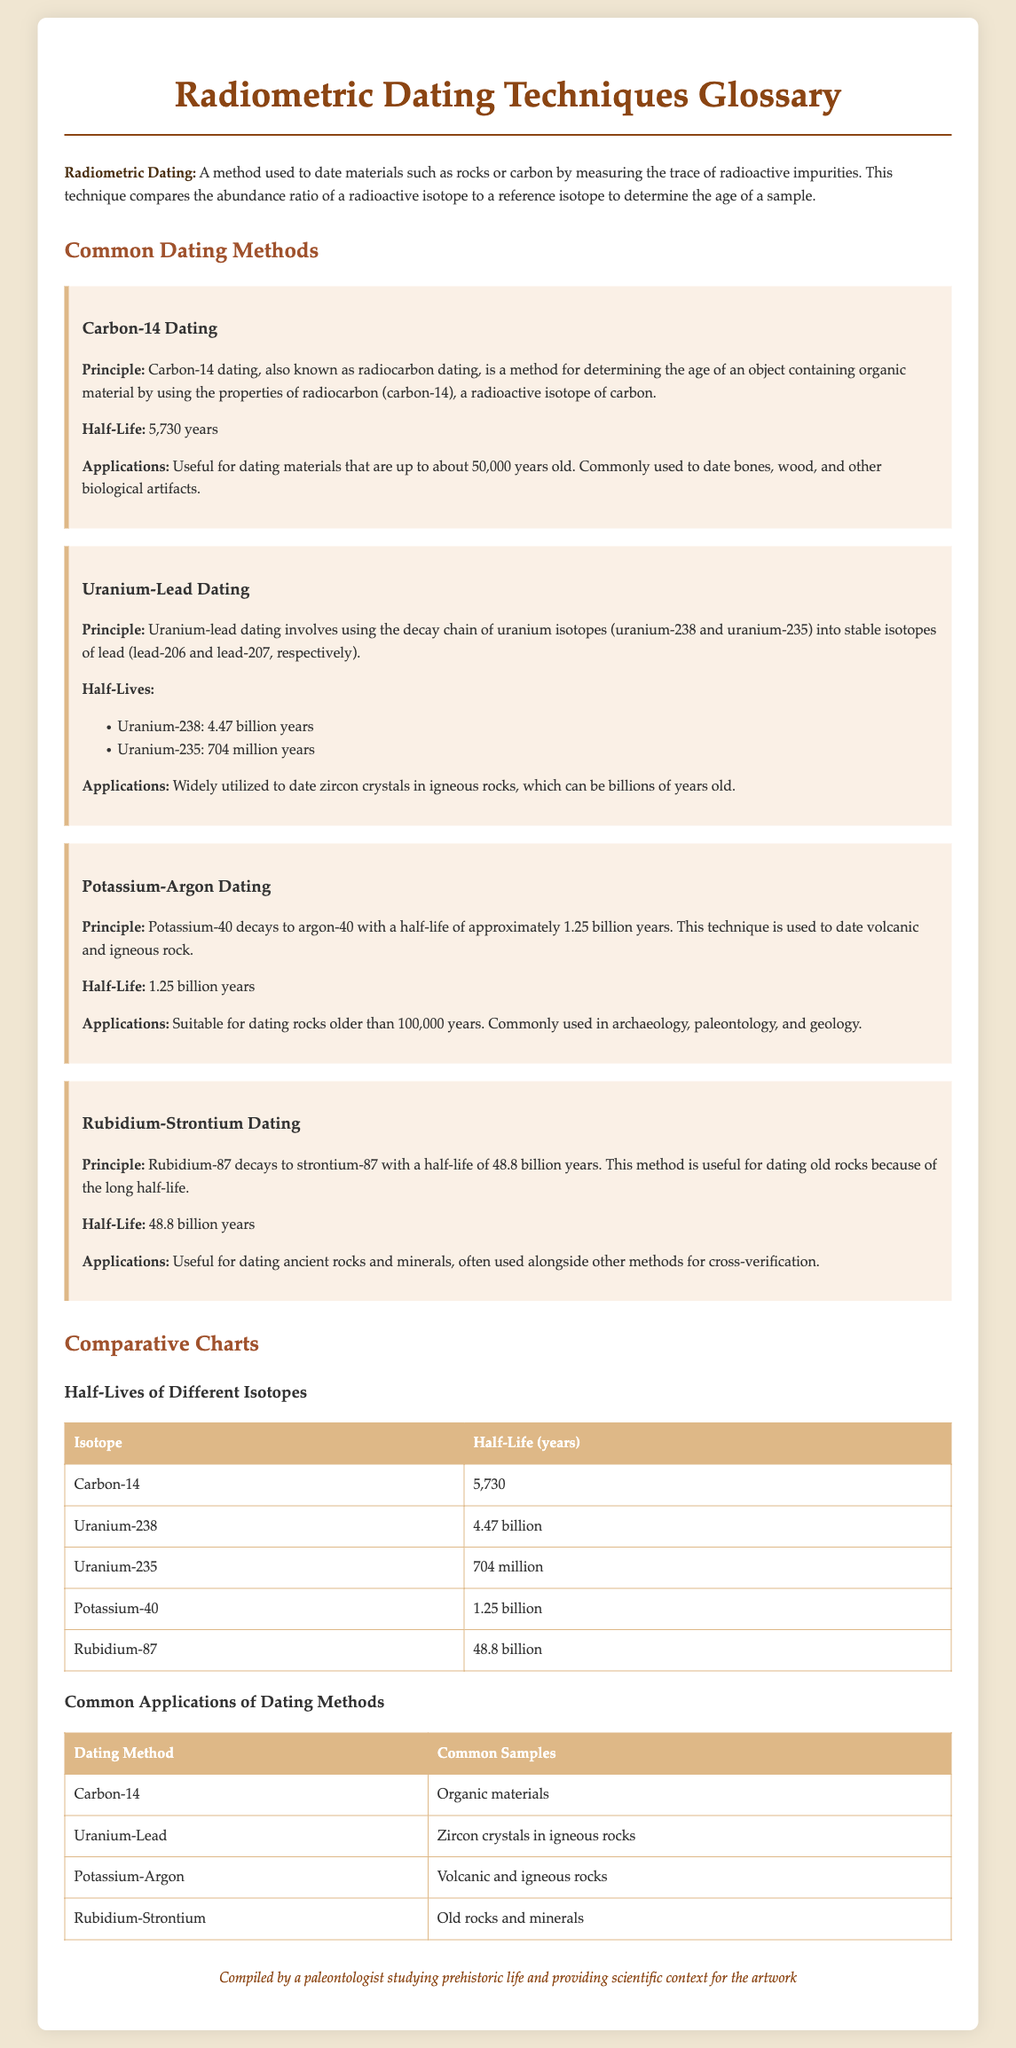What is radiometric dating? Radiometric dating is defined as a method used to date materials such as rocks or carbon by measuring the trace of radioactive impurities.
Answer: A method used to date materials What is the half-life of Carbon-14? The half-life of Carbon-14 is stated in the document as 5,730 years.
Answer: 5,730 years What applications does Potassium-Argon dating have? The applications section mentions that Potassium-Argon dating is commonly used in archaeology, paleontology, and geology for dating rocks older than 100,000 years.
Answer: Archaeology, paleontology, and geology Which isotope has the longest half-life? By comparing the half-lives listed in the comparative charts, Rubidium-87 is shown to have the longest half-life of 48.8 billion years.
Answer: Rubidium-87 What common samples are dated using Uranium-Lead? The document specifies that Uranium-Lead dating is utilized to date zircon crystals in igneous rocks.
Answer: Zircon crystals in igneous rocks How many common dating methods are mentioned in the document? The document lists four common dating methods, which are Carbon-14, Uranium-Lead, Potassium-Argon, and Rubidium-Strontium.
Answer: Four dating methods What is the purpose of the comparative charts? The purpose of the comparative charts is to showcase the half-lives and applications of different isotopes, providing a clearer understanding of each method.
Answer: To showcase half-lives and applications What is a scientific context provided by the glossary author? The author, a paleontologist, provides scientific context specifically for prehistoric life and artwork, as noted in the footer.
Answer: Prehistoric life and artwork 